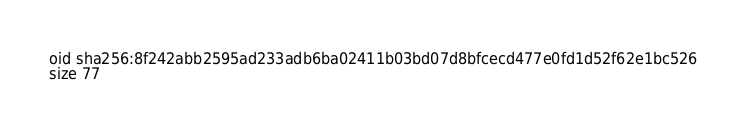Convert code to text. <code><loc_0><loc_0><loc_500><loc_500><_YAML_>oid sha256:8f242abb2595ad233adb6ba02411b03bd07d8bfcecd477e0fd1d52f62e1bc526
size 77
</code> 